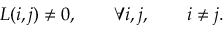Convert formula to latex. <formula><loc_0><loc_0><loc_500><loc_500>L ( i , j ) \ne 0 , \quad \forall i , j , \quad i \ne j .</formula> 